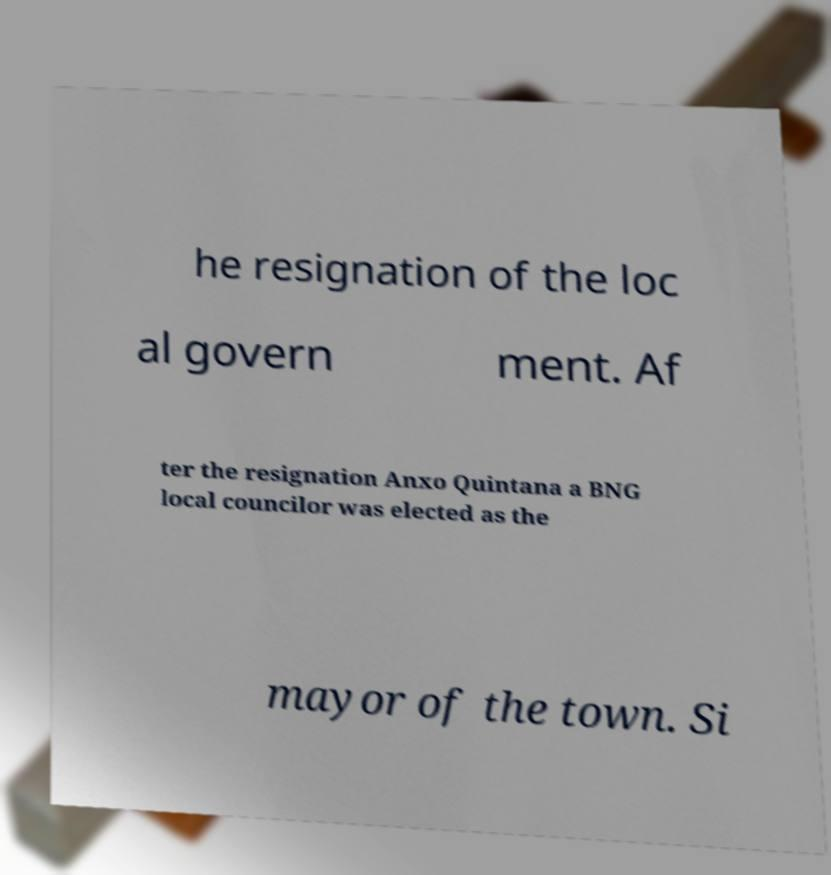Can you accurately transcribe the text from the provided image for me? he resignation of the loc al govern ment. Af ter the resignation Anxo Quintana a BNG local councilor was elected as the mayor of the town. Si 